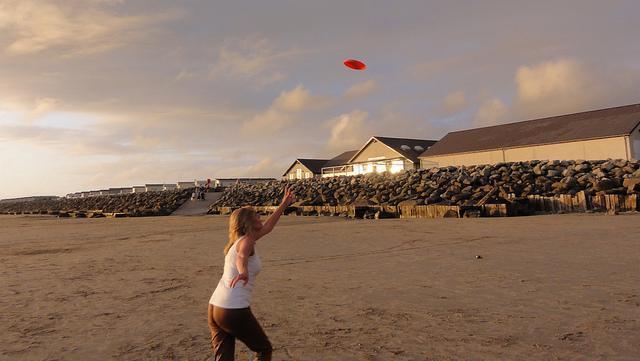What cut of shirt is she wearing?
Answer the question by selecting the correct answer among the 4 following choices.
Options: T-shirt, tank top, crop top, turtleneck. Tank top. 